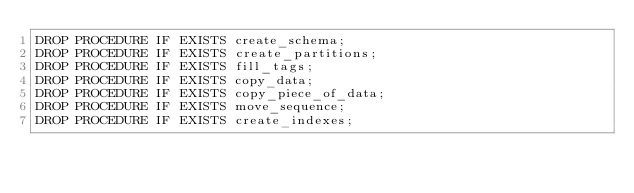<code> <loc_0><loc_0><loc_500><loc_500><_SQL_>DROP PROCEDURE IF EXISTS create_schema;
DROP PROCEDURE IF EXISTS create_partitions;
DROP PROCEDURE IF EXISTS fill_tags;
DROP PROCEDURE IF EXISTS copy_data;
DROP PROCEDURE IF EXISTS copy_piece_of_data;
DROP PROCEDURE IF EXISTS move_sequence;
DROP PROCEDURE IF EXISTS create_indexes;
</code> 